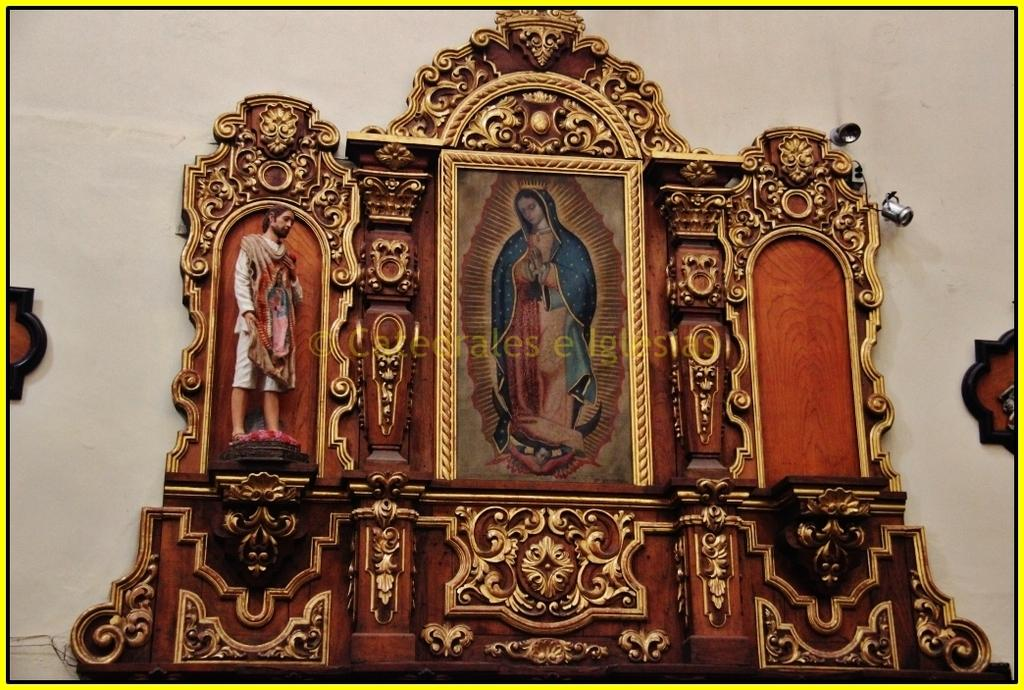What is located on the wall in the middle of the image? There is a frame on the wall in the middle of the image. What type of reward is depicted in the frame on the wall? There is no reward depicted in the frame on the wall; the fact only mentions the presence of a frame. 